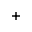Convert formula to latex. <formula><loc_0><loc_0><loc_500><loc_500>+</formula> 